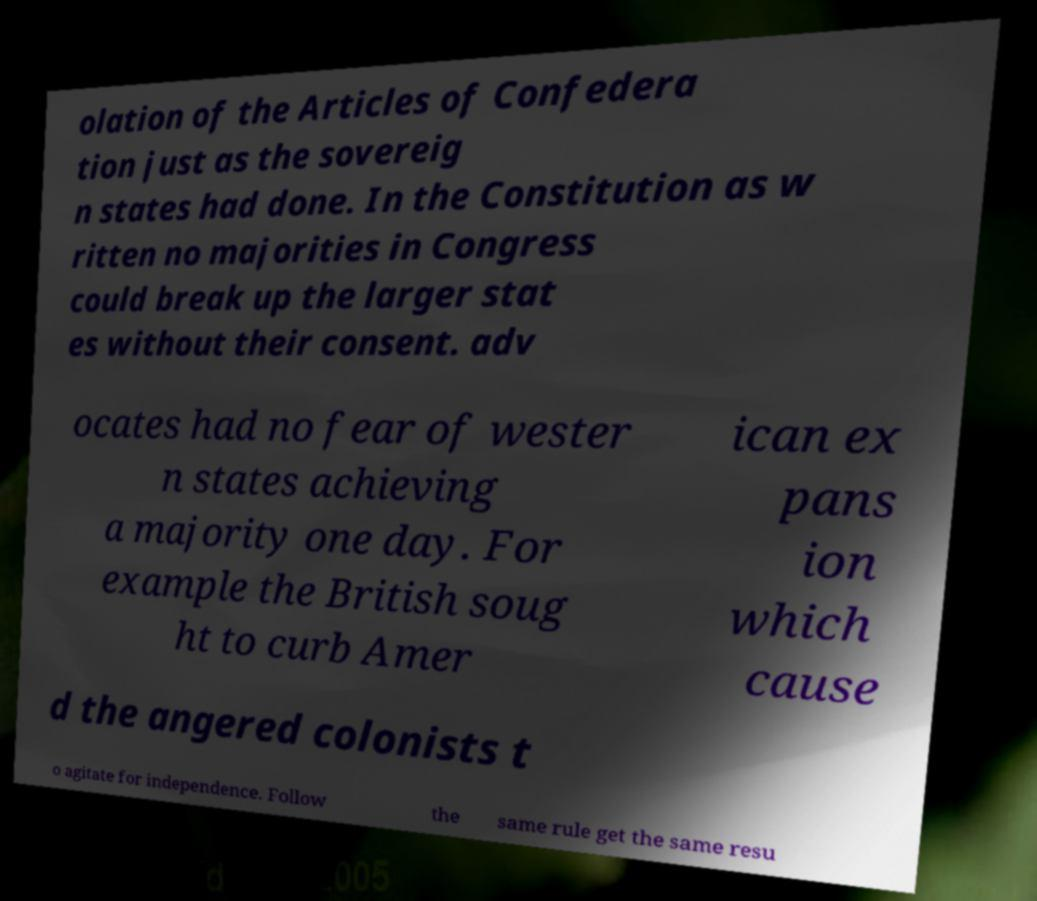For documentation purposes, I need the text within this image transcribed. Could you provide that? olation of the Articles of Confedera tion just as the sovereig n states had done. In the Constitution as w ritten no majorities in Congress could break up the larger stat es without their consent. adv ocates had no fear of wester n states achieving a majority one day. For example the British soug ht to curb Amer ican ex pans ion which cause d the angered colonists t o agitate for independence. Follow the same rule get the same resu 